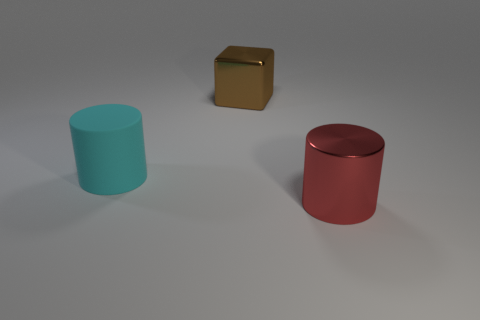There is a red object that is the same material as the block; what size is it?
Provide a succinct answer. Large. What shape is the large shiny thing that is to the left of the large red object that is in front of the cylinder on the left side of the big brown metal thing?
Your answer should be compact. Cube. Is the number of big cyan things that are behind the cyan cylinder the same as the number of small blue rubber cubes?
Keep it short and to the point. Yes. Is the shape of the large cyan thing the same as the large red metallic object?
Make the answer very short. Yes. How many objects are large cylinders that are behind the big red shiny cylinder or tiny red shiny things?
Your response must be concise. 1. Are there the same number of large red things behind the large shiny cylinder and large cyan rubber objects that are to the left of the big rubber object?
Provide a short and direct response. Yes. How many other things are the same shape as the large brown object?
Your response must be concise. 0. Is the size of the cylinder that is on the left side of the brown block the same as the object that is behind the rubber cylinder?
Provide a short and direct response. Yes. What number of spheres are either large metal things or big yellow metal objects?
Provide a short and direct response. 0. What number of metal objects are large cyan objects or small brown cylinders?
Your answer should be very brief. 0. 